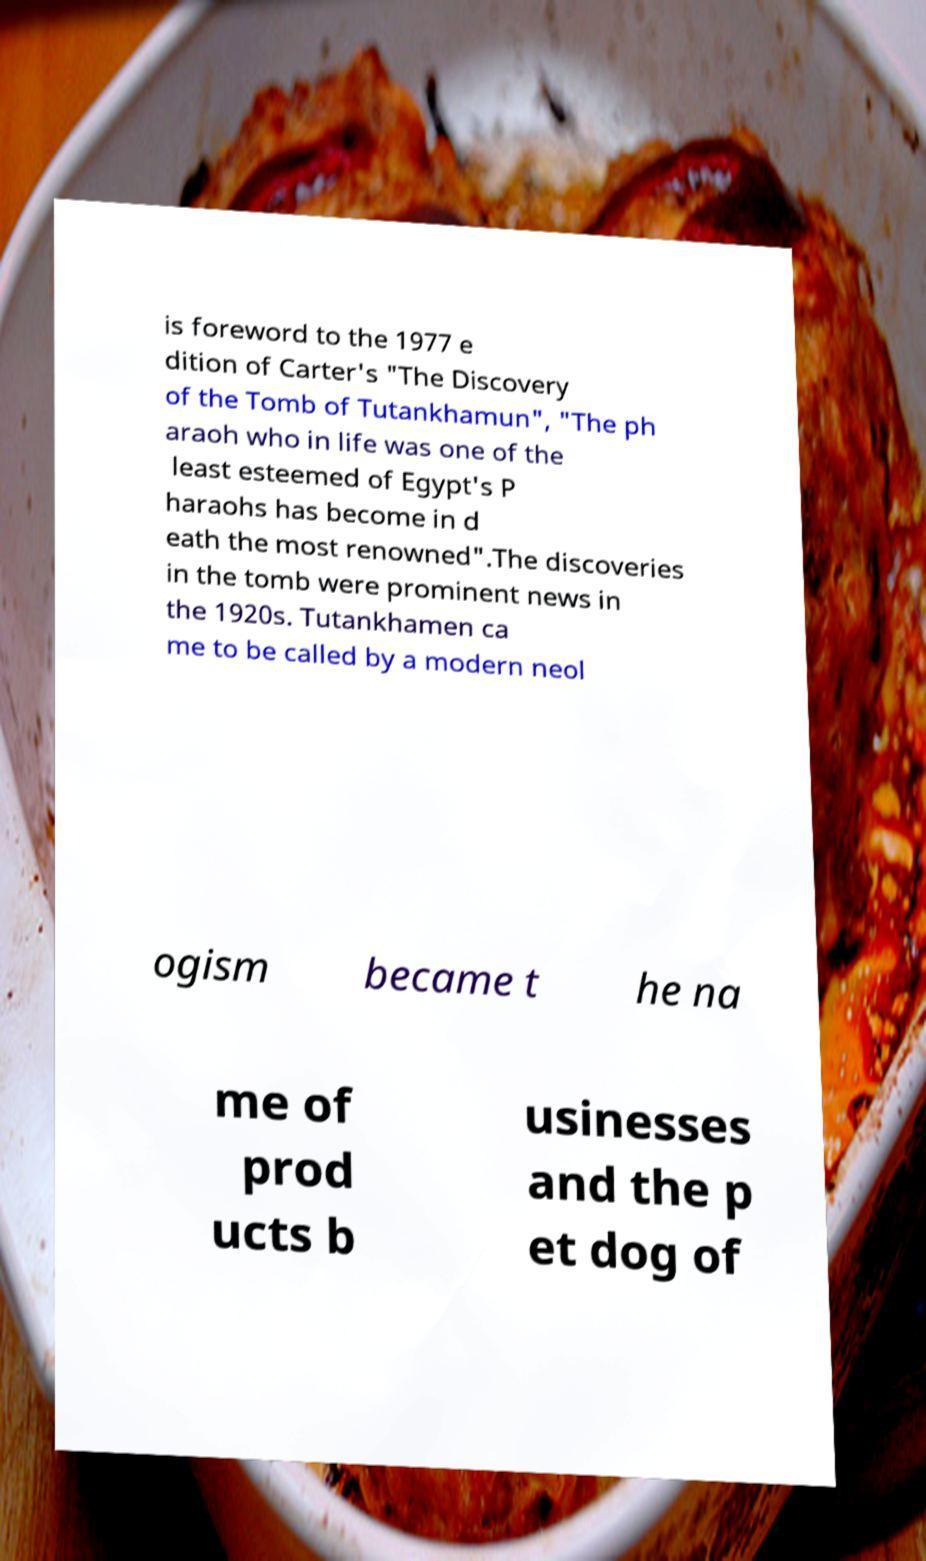Please read and relay the text visible in this image. What does it say? is foreword to the 1977 e dition of Carter's "The Discovery of the Tomb of Tutankhamun", "The ph araoh who in life was one of the least esteemed of Egypt's P haraohs has become in d eath the most renowned".The discoveries in the tomb were prominent news in the 1920s. Tutankhamen ca me to be called by a modern neol ogism became t he na me of prod ucts b usinesses and the p et dog of 